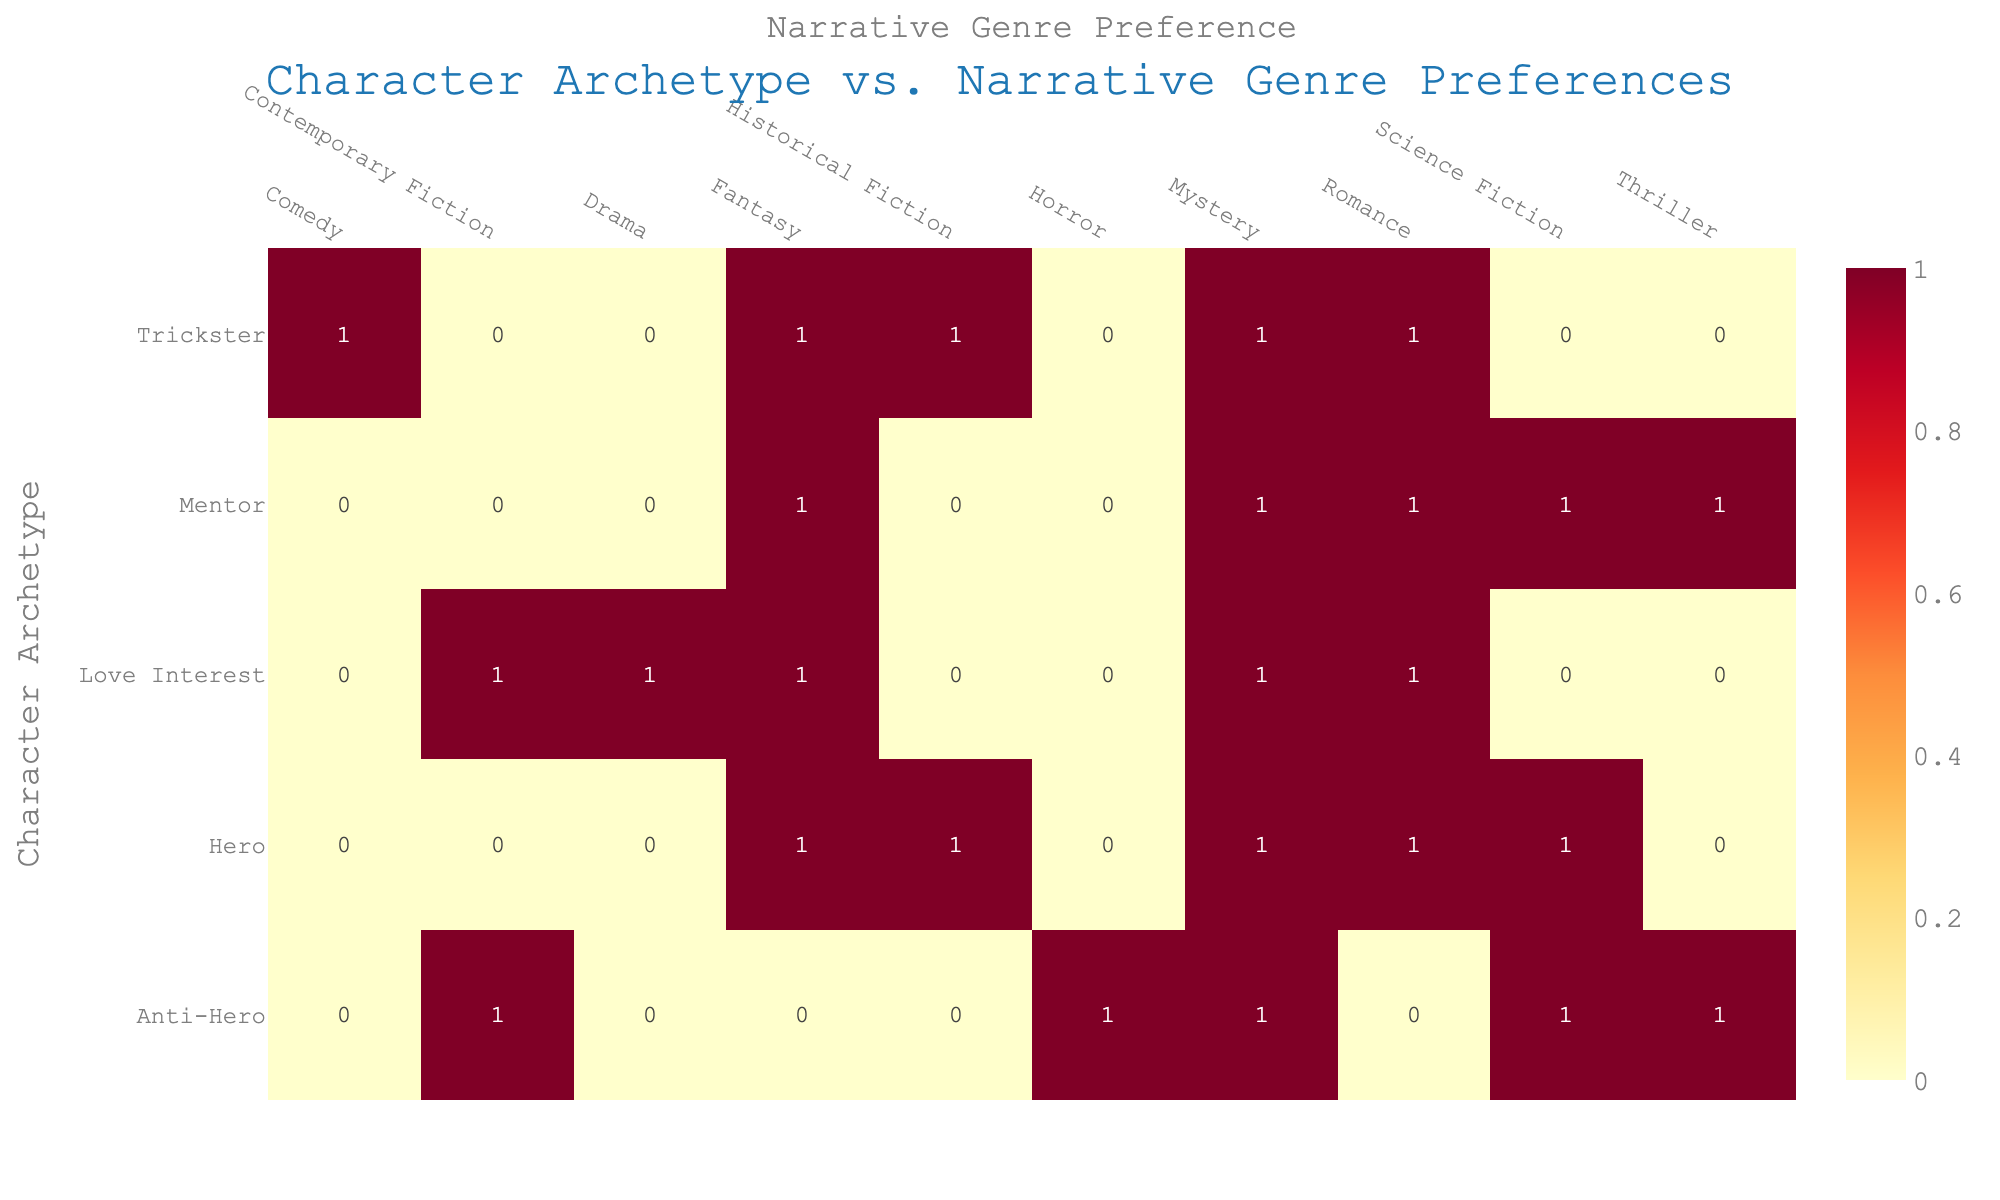What is the total number of narrative genres preferred for the Hero archetype? The table shows the genres associated with the Hero archetype: Fantasy, Science Fiction, Romance, Mystery, and Historical Fiction. Counting these gives 5 genres.
Answer: 5 Which character archetype has the highest number of preferred narrative genres? Looking at the table, the Hero, Mentor, Anti-Hero, Trickster, and Love Interest each show how many genres they align with. Hero has 5, Mentor has 5, Anti-Hero has 5, Trickster has 5, and Love Interest has 5. Since all have the same count, no single archetype stands out.
Answer: Yes, all have equal counts Is there a preferred genre among the different character archetypes? By examining the table, we can see how often each genre appears. Romance appears 4 times across Hero, Mentor, Trickster, and Love Interest; Fantasy also appears 4 times under Hero, Mentor, Trickster, and Love Interest. Other genres have fewer instances, indicating that Romance and Fantasy are among the more favored.
Answer: Yes, Romance and Fantasy are preferred How many unique narrative genres are preferred by the Anti-Hero archetype? The Anti-Hero shows the following genres: Science Fiction, Mystery, Thriller, Contemporary Fiction, and Horror. Counting these gives us 5 unique genres.
Answer: 5 What is the total count of preferences for the Trickster archetype across all genres? From the table, the Trickster appears in Fantasy, Romance, Mystery, Historical Fiction, and Comedy. The count of these genres is 5, making the total preferences for Trickster equal to 5.
Answer: 5 Does the Love Interest character archetype prefer any genres that are also preferred by the Mentor archetype? By analyzing both the Love Interest and Mentor's preferred genres, we see that Mentor prefers Romance, and Love Interest prefers Romance too. Thus, both share this genre preference.
Answer: Yes, they both prefer Romance What is the average number of genres preferred across all character archetypes? Totaling the number of preferences: Hero (5) + Mentor (5) + Anti-Hero (5) + Trickster (5) + Love Interest (5) = 25. There are 5 character archetypes, so we divide 25 by 5 to find that the average is 5.
Answer: 5 Are there any genres preferred only by one character archetype? By checking each genre against character archetypes, we see that Drama, associated only with Love Interest, does not appear with any other archetype. Thus, it is unique to this character.
Answer: Yes, Drama is unique to Love Interest Which character archetype has the least preferred genres? Since all archetypes—Hero, Mentor, Anti-Hero, Trickster, and Love Interest—have 5 preferences each, none is less or more preferred; they all have equal counts.
Answer: None; they all have equal counts 